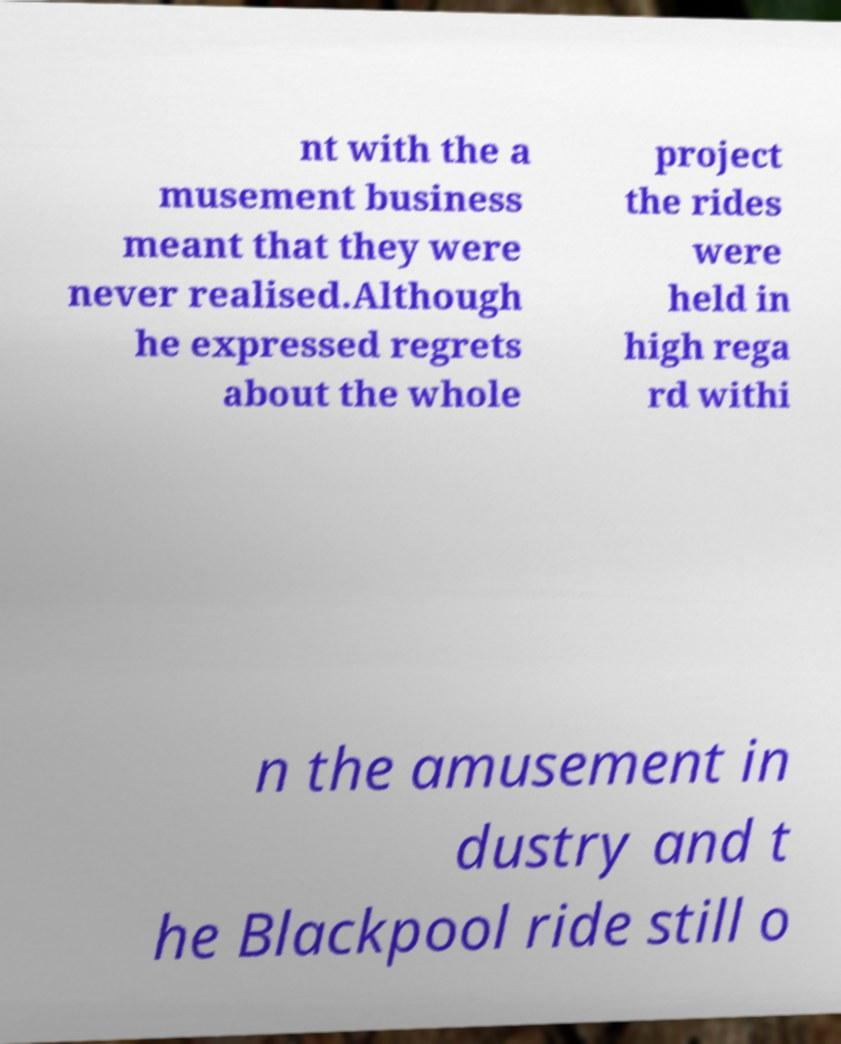Please identify and transcribe the text found in this image. nt with the a musement business meant that they were never realised.Although he expressed regrets about the whole project the rides were held in high rega rd withi n the amusement in dustry and t he Blackpool ride still o 